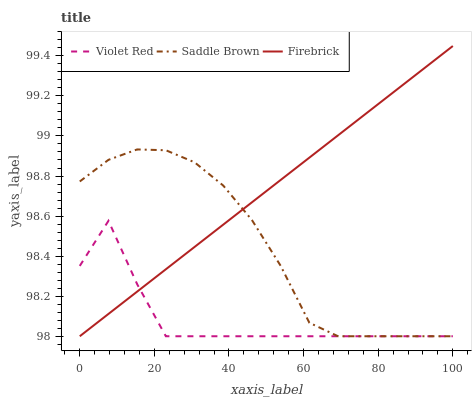Does Saddle Brown have the minimum area under the curve?
Answer yes or no. No. Does Saddle Brown have the maximum area under the curve?
Answer yes or no. No. Is Saddle Brown the smoothest?
Answer yes or no. No. Is Saddle Brown the roughest?
Answer yes or no. No. Does Saddle Brown have the highest value?
Answer yes or no. No. 